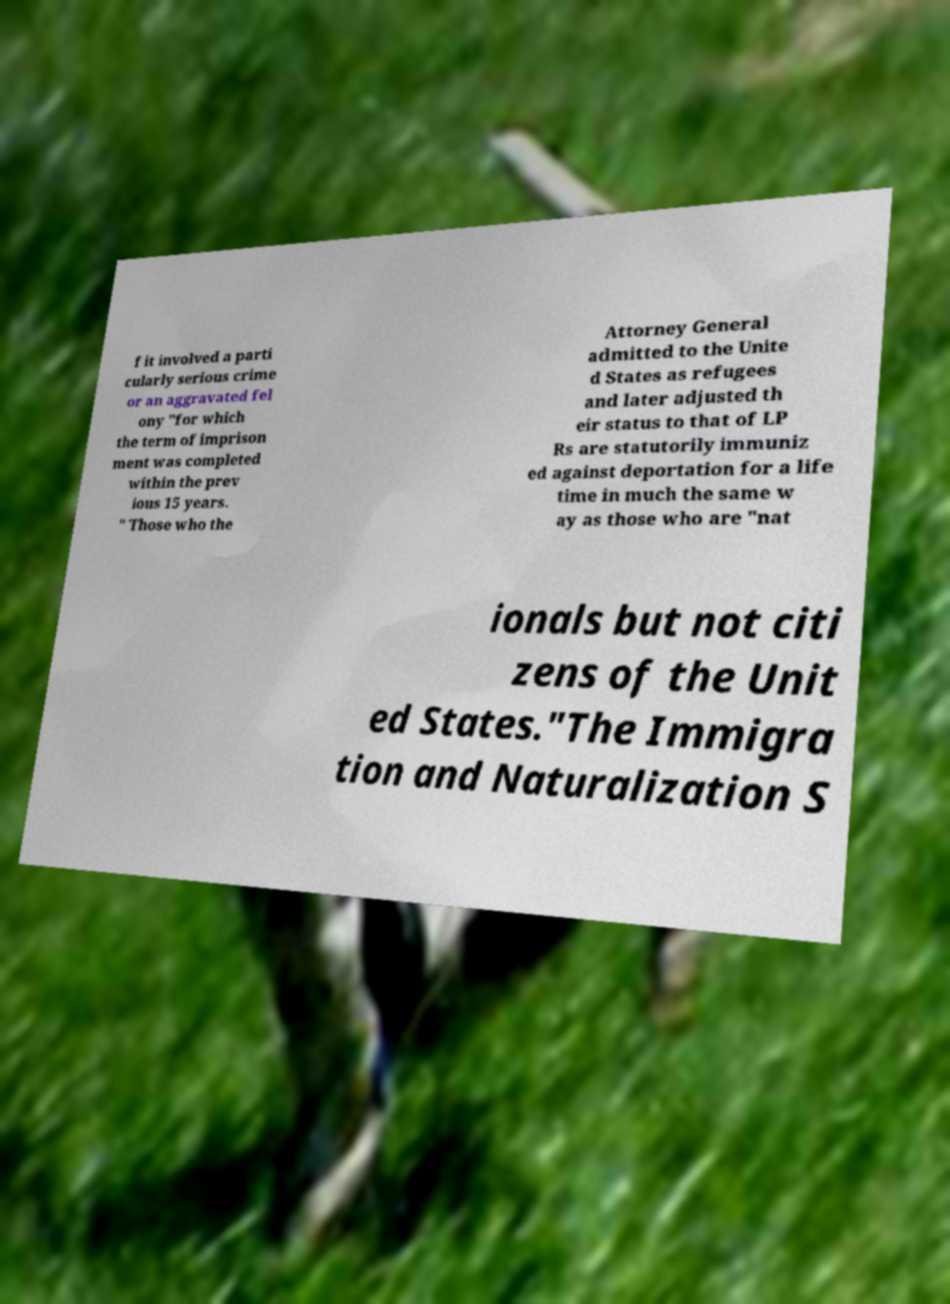Can you accurately transcribe the text from the provided image for me? f it involved a parti cularly serious crime or an aggravated fel ony "for which the term of imprison ment was completed within the prev ious 15 years. " Those who the Attorney General admitted to the Unite d States as refugees and later adjusted th eir status to that of LP Rs are statutorily immuniz ed against deportation for a life time in much the same w ay as those who are "nat ionals but not citi zens of the Unit ed States."The Immigra tion and Naturalization S 